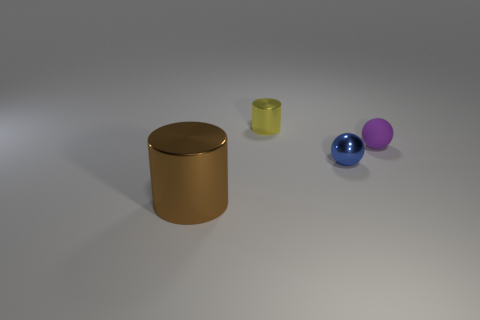There is a tiny thing to the left of the tiny blue ball; what is its color?
Ensure brevity in your answer.  Yellow. Are there more metallic spheres that are behind the tiny rubber ball than small purple spheres?
Your answer should be compact. No. What number of other objects are there of the same size as the brown metal cylinder?
Your response must be concise. 0. There is a tiny purple sphere; what number of brown metal objects are in front of it?
Your response must be concise. 1. Are there an equal number of tiny cylinders in front of the big object and small purple spheres in front of the purple sphere?
Give a very brief answer. Yes. What size is the metallic object that is the same shape as the small purple rubber thing?
Your answer should be compact. Small. What is the shape of the metal object behind the small rubber thing?
Offer a terse response. Cylinder. Are the cylinder behind the tiny blue shiny ball and the cylinder in front of the shiny ball made of the same material?
Keep it short and to the point. Yes. There is a small blue thing; what shape is it?
Provide a succinct answer. Sphere. Are there the same number of large brown shiny objects that are on the right side of the yellow cylinder and small green shiny cubes?
Offer a terse response. Yes. 